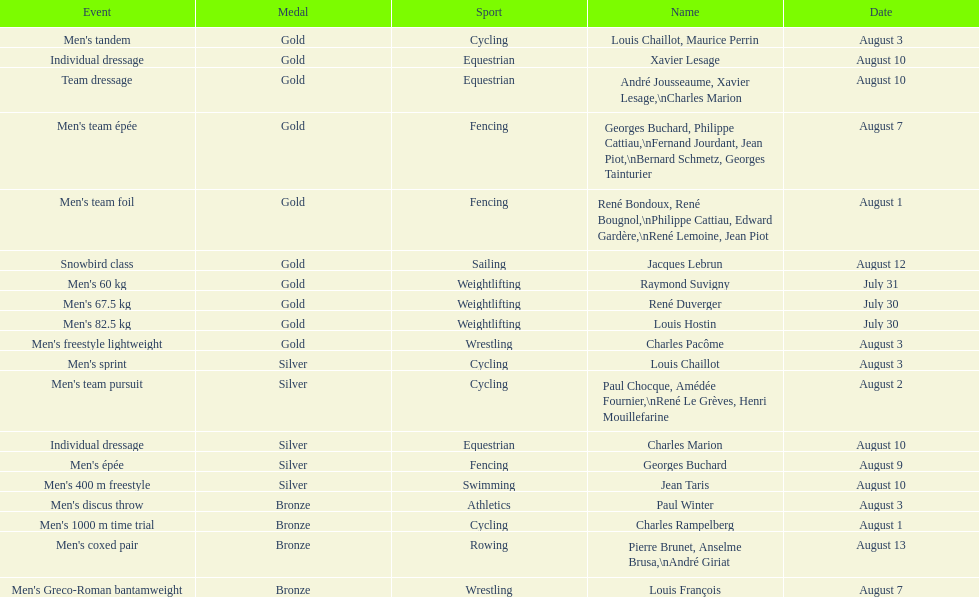What is next date that is listed after august 7th? August 1. 